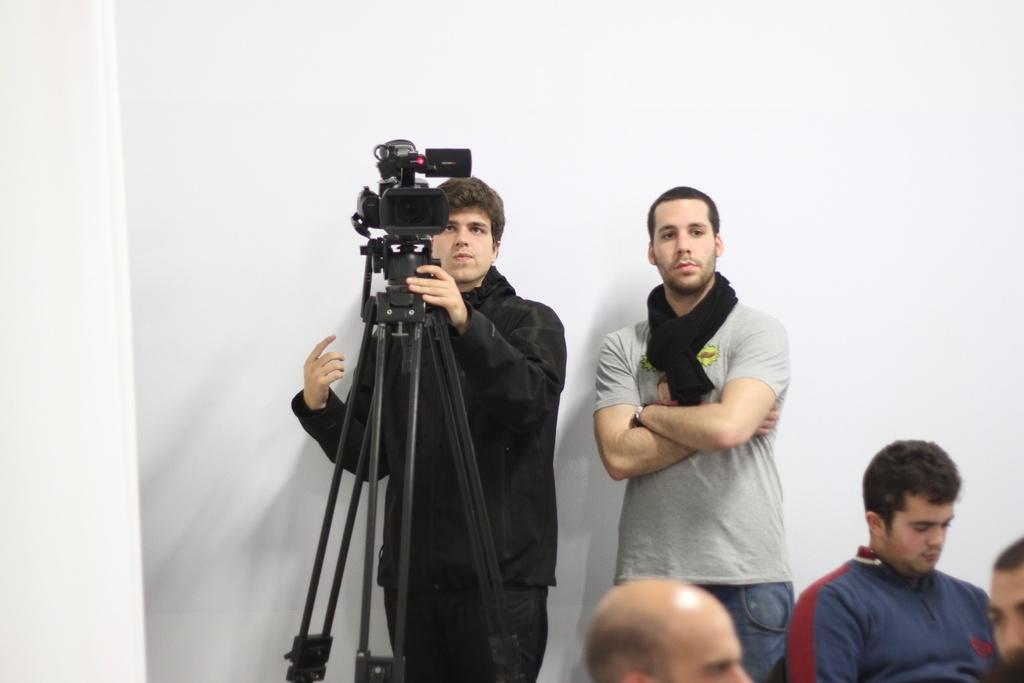In one or two sentences, can you explain what this image depicts? In this image I can see the few people and one person is holding the camera. The camera is on the stand. Background is in white color. 